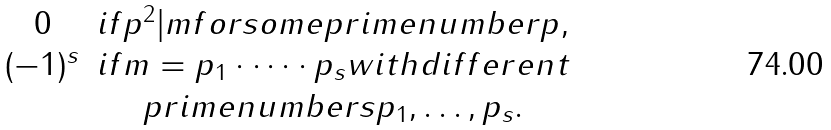<formula> <loc_0><loc_0><loc_500><loc_500>\begin{matrix} 0 & i f p ^ { 2 } | m f o r s o m e p r i m e n u m b e r p , \\ ( - 1 ) ^ { s } & i f m = p _ { 1 } \cdot \dots \cdot p _ { s } w i t h d i f f e r e n t \\ & p r i m e n u m b e r s p _ { 1 } , \dots , p _ { s } . \end{matrix}</formula> 